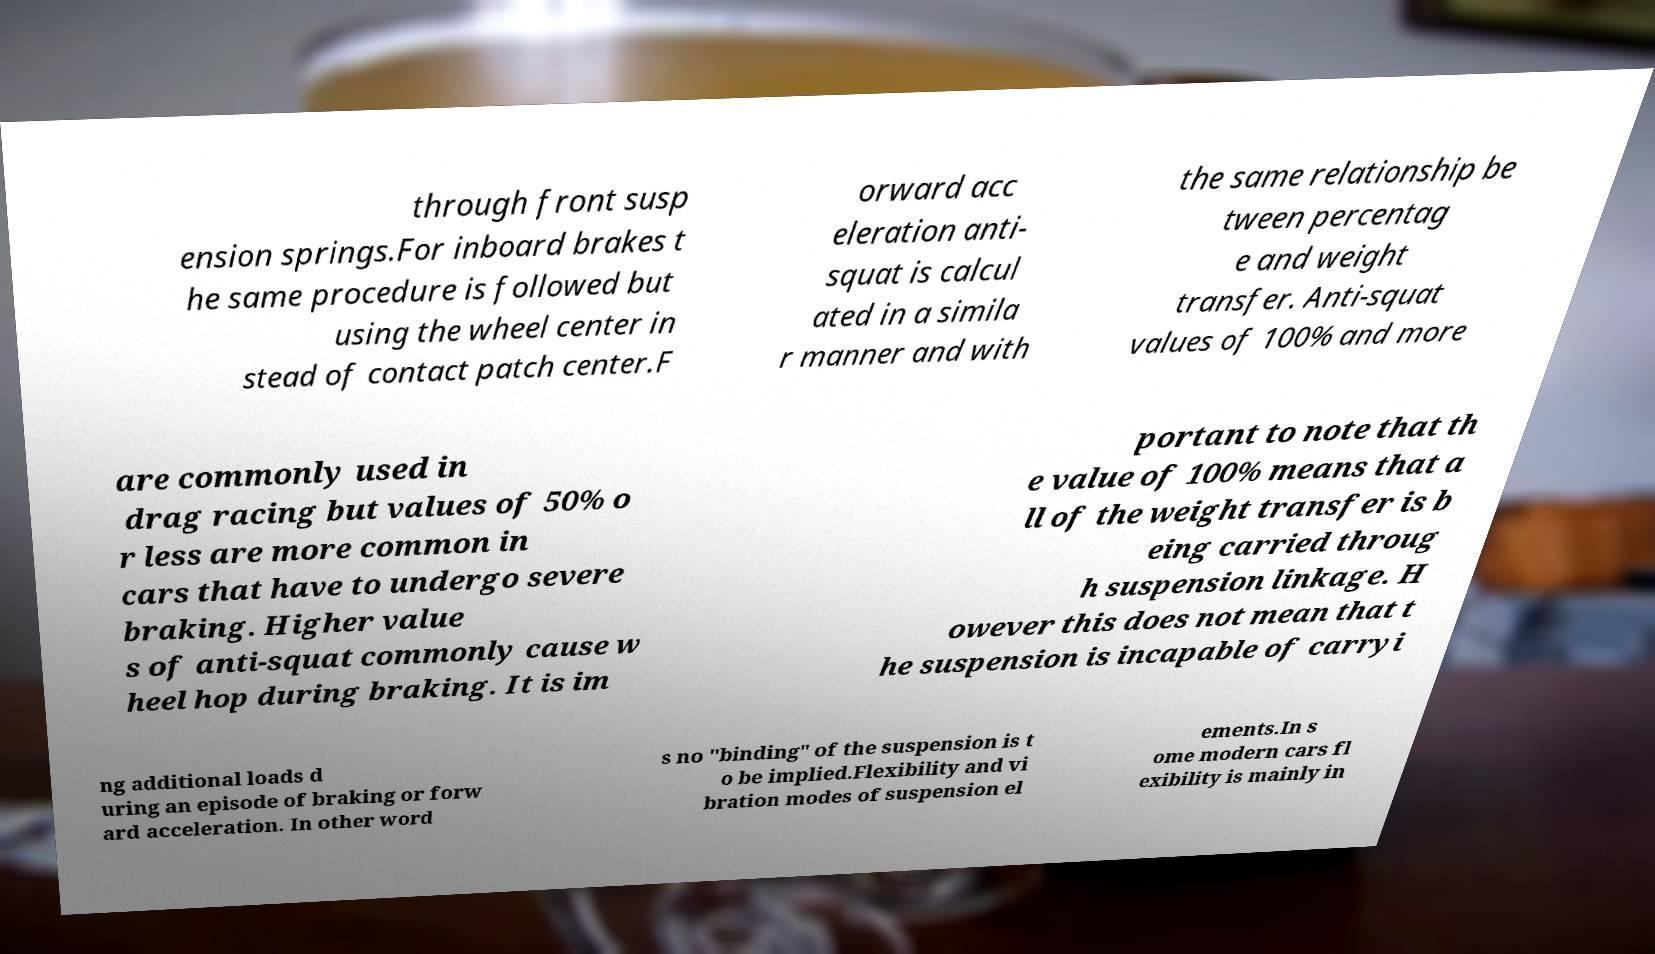Can you read and provide the text displayed in the image?This photo seems to have some interesting text. Can you extract and type it out for me? through front susp ension springs.For inboard brakes t he same procedure is followed but using the wheel center in stead of contact patch center.F orward acc eleration anti- squat is calcul ated in a simila r manner and with the same relationship be tween percentag e and weight transfer. Anti-squat values of 100% and more are commonly used in drag racing but values of 50% o r less are more common in cars that have to undergo severe braking. Higher value s of anti-squat commonly cause w heel hop during braking. It is im portant to note that th e value of 100% means that a ll of the weight transfer is b eing carried throug h suspension linkage. H owever this does not mean that t he suspension is incapable of carryi ng additional loads d uring an episode of braking or forw ard acceleration. In other word s no "binding" of the suspension is t o be implied.Flexibility and vi bration modes of suspension el ements.In s ome modern cars fl exibility is mainly in 